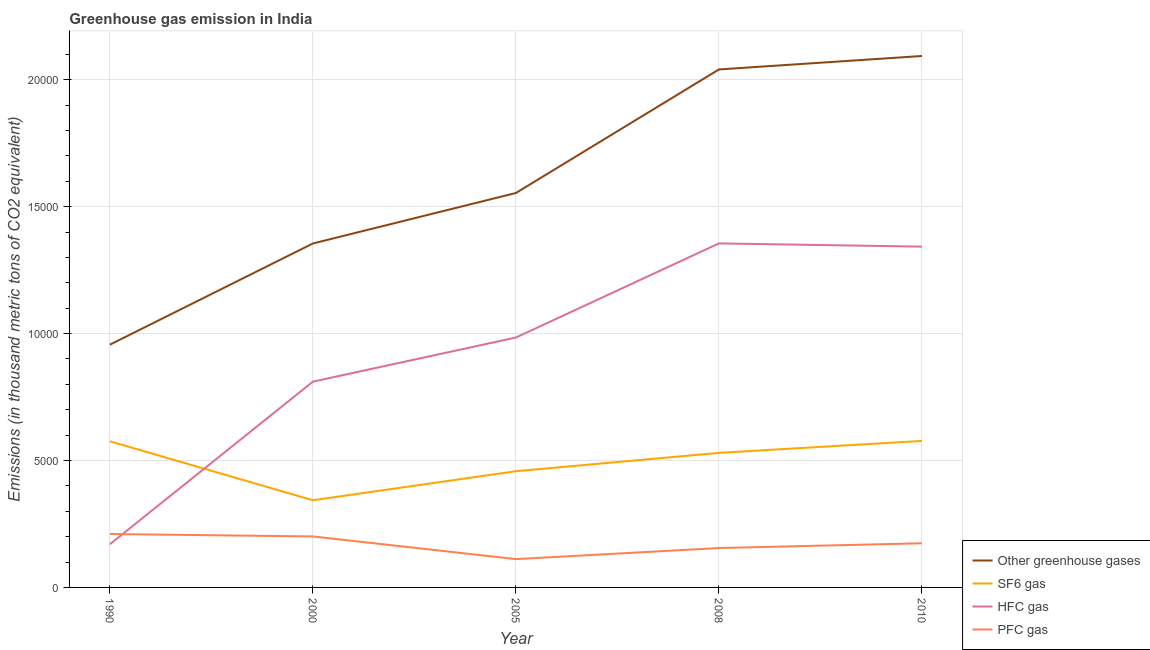How many different coloured lines are there?
Give a very brief answer. 4. What is the emission of hfc gas in 2000?
Your answer should be very brief. 8107.2. Across all years, what is the maximum emission of pfc gas?
Make the answer very short. 2104. Across all years, what is the minimum emission of sf6 gas?
Offer a terse response. 3434.7. In which year was the emission of sf6 gas maximum?
Provide a succinct answer. 2010. In which year was the emission of pfc gas minimum?
Offer a terse response. 2005. What is the total emission of greenhouse gases in the graph?
Your answer should be compact. 8.00e+04. What is the difference between the emission of hfc gas in 2000 and that in 2008?
Your response must be concise. -5446.5. What is the difference between the emission of hfc gas in 2000 and the emission of sf6 gas in 2008?
Give a very brief answer. 2805.8. What is the average emission of pfc gas per year?
Provide a succinct answer. 1704.08. In the year 2008, what is the difference between the emission of sf6 gas and emission of greenhouse gases?
Your answer should be very brief. -1.51e+04. In how many years, is the emission of hfc gas greater than 8000 thousand metric tons?
Give a very brief answer. 4. What is the ratio of the emission of sf6 gas in 2000 to that in 2010?
Ensure brevity in your answer.  0.6. Is the difference between the emission of greenhouse gases in 1990 and 2008 greater than the difference between the emission of sf6 gas in 1990 and 2008?
Provide a succinct answer. No. What is the difference between the highest and the lowest emission of hfc gas?
Keep it short and to the point. 1.19e+04. In how many years, is the emission of greenhouse gases greater than the average emission of greenhouse gases taken over all years?
Your answer should be very brief. 2. Is the sum of the emission of sf6 gas in 1990 and 2010 greater than the maximum emission of hfc gas across all years?
Ensure brevity in your answer.  No. Is it the case that in every year, the sum of the emission of greenhouse gases and emission of sf6 gas is greater than the sum of emission of pfc gas and emission of hfc gas?
Offer a very short reply. Yes. Does the emission of greenhouse gases monotonically increase over the years?
Your response must be concise. Yes. Is the emission of sf6 gas strictly greater than the emission of greenhouse gases over the years?
Your answer should be very brief. No. Is the emission of sf6 gas strictly less than the emission of hfc gas over the years?
Make the answer very short. No. What is the difference between two consecutive major ticks on the Y-axis?
Your response must be concise. 5000. Are the values on the major ticks of Y-axis written in scientific E-notation?
Your answer should be very brief. No. Does the graph contain any zero values?
Offer a very short reply. No. Does the graph contain grids?
Your answer should be very brief. Yes. How many legend labels are there?
Keep it short and to the point. 4. How are the legend labels stacked?
Make the answer very short. Vertical. What is the title of the graph?
Offer a very short reply. Greenhouse gas emission in India. Does "Third 20% of population" appear as one of the legend labels in the graph?
Give a very brief answer. No. What is the label or title of the Y-axis?
Ensure brevity in your answer.  Emissions (in thousand metric tons of CO2 equivalent). What is the Emissions (in thousand metric tons of CO2 equivalent) in Other greenhouse gases in 1990?
Your answer should be compact. 9563.6. What is the Emissions (in thousand metric tons of CO2 equivalent) of SF6 gas in 1990?
Offer a very short reply. 5757.5. What is the Emissions (in thousand metric tons of CO2 equivalent) in HFC gas in 1990?
Offer a terse response. 1702.1. What is the Emissions (in thousand metric tons of CO2 equivalent) in PFC gas in 1990?
Keep it short and to the point. 2104. What is the Emissions (in thousand metric tons of CO2 equivalent) of Other greenhouse gases in 2000?
Provide a short and direct response. 1.36e+04. What is the Emissions (in thousand metric tons of CO2 equivalent) in SF6 gas in 2000?
Provide a short and direct response. 3434.7. What is the Emissions (in thousand metric tons of CO2 equivalent) of HFC gas in 2000?
Your answer should be compact. 8107.2. What is the Emissions (in thousand metric tons of CO2 equivalent) of PFC gas in 2000?
Offer a very short reply. 2008.8. What is the Emissions (in thousand metric tons of CO2 equivalent) of Other greenhouse gases in 2005?
Give a very brief answer. 1.55e+04. What is the Emissions (in thousand metric tons of CO2 equivalent) in SF6 gas in 2005?
Offer a very short reply. 4578.7. What is the Emissions (in thousand metric tons of CO2 equivalent) of HFC gas in 2005?
Provide a short and direct response. 9845.2. What is the Emissions (in thousand metric tons of CO2 equivalent) in PFC gas in 2005?
Give a very brief answer. 1115.8. What is the Emissions (in thousand metric tons of CO2 equivalent) of Other greenhouse gases in 2008?
Give a very brief answer. 2.04e+04. What is the Emissions (in thousand metric tons of CO2 equivalent) of SF6 gas in 2008?
Offer a very short reply. 5301.4. What is the Emissions (in thousand metric tons of CO2 equivalent) in HFC gas in 2008?
Give a very brief answer. 1.36e+04. What is the Emissions (in thousand metric tons of CO2 equivalent) of PFC gas in 2008?
Offer a terse response. 1551.8. What is the Emissions (in thousand metric tons of CO2 equivalent) in Other greenhouse gases in 2010?
Keep it short and to the point. 2.09e+04. What is the Emissions (in thousand metric tons of CO2 equivalent) in SF6 gas in 2010?
Offer a terse response. 5772. What is the Emissions (in thousand metric tons of CO2 equivalent) of HFC gas in 2010?
Offer a very short reply. 1.34e+04. What is the Emissions (in thousand metric tons of CO2 equivalent) in PFC gas in 2010?
Your response must be concise. 1740. Across all years, what is the maximum Emissions (in thousand metric tons of CO2 equivalent) in Other greenhouse gases?
Offer a terse response. 2.09e+04. Across all years, what is the maximum Emissions (in thousand metric tons of CO2 equivalent) in SF6 gas?
Provide a short and direct response. 5772. Across all years, what is the maximum Emissions (in thousand metric tons of CO2 equivalent) in HFC gas?
Ensure brevity in your answer.  1.36e+04. Across all years, what is the maximum Emissions (in thousand metric tons of CO2 equivalent) in PFC gas?
Provide a short and direct response. 2104. Across all years, what is the minimum Emissions (in thousand metric tons of CO2 equivalent) of Other greenhouse gases?
Your response must be concise. 9563.6. Across all years, what is the minimum Emissions (in thousand metric tons of CO2 equivalent) in SF6 gas?
Offer a very short reply. 3434.7. Across all years, what is the minimum Emissions (in thousand metric tons of CO2 equivalent) of HFC gas?
Provide a succinct answer. 1702.1. Across all years, what is the minimum Emissions (in thousand metric tons of CO2 equivalent) in PFC gas?
Provide a short and direct response. 1115.8. What is the total Emissions (in thousand metric tons of CO2 equivalent) in Other greenhouse gases in the graph?
Provide a succinct answer. 8.00e+04. What is the total Emissions (in thousand metric tons of CO2 equivalent) in SF6 gas in the graph?
Your answer should be compact. 2.48e+04. What is the total Emissions (in thousand metric tons of CO2 equivalent) in HFC gas in the graph?
Keep it short and to the point. 4.66e+04. What is the total Emissions (in thousand metric tons of CO2 equivalent) of PFC gas in the graph?
Make the answer very short. 8520.4. What is the difference between the Emissions (in thousand metric tons of CO2 equivalent) in Other greenhouse gases in 1990 and that in 2000?
Provide a succinct answer. -3987.1. What is the difference between the Emissions (in thousand metric tons of CO2 equivalent) in SF6 gas in 1990 and that in 2000?
Your response must be concise. 2322.8. What is the difference between the Emissions (in thousand metric tons of CO2 equivalent) in HFC gas in 1990 and that in 2000?
Your answer should be compact. -6405.1. What is the difference between the Emissions (in thousand metric tons of CO2 equivalent) in PFC gas in 1990 and that in 2000?
Provide a succinct answer. 95.2. What is the difference between the Emissions (in thousand metric tons of CO2 equivalent) in Other greenhouse gases in 1990 and that in 2005?
Offer a very short reply. -5976.1. What is the difference between the Emissions (in thousand metric tons of CO2 equivalent) in SF6 gas in 1990 and that in 2005?
Provide a short and direct response. 1178.8. What is the difference between the Emissions (in thousand metric tons of CO2 equivalent) in HFC gas in 1990 and that in 2005?
Offer a terse response. -8143.1. What is the difference between the Emissions (in thousand metric tons of CO2 equivalent) of PFC gas in 1990 and that in 2005?
Keep it short and to the point. 988.2. What is the difference between the Emissions (in thousand metric tons of CO2 equivalent) in Other greenhouse gases in 1990 and that in 2008?
Offer a terse response. -1.08e+04. What is the difference between the Emissions (in thousand metric tons of CO2 equivalent) of SF6 gas in 1990 and that in 2008?
Ensure brevity in your answer.  456.1. What is the difference between the Emissions (in thousand metric tons of CO2 equivalent) of HFC gas in 1990 and that in 2008?
Provide a short and direct response. -1.19e+04. What is the difference between the Emissions (in thousand metric tons of CO2 equivalent) of PFC gas in 1990 and that in 2008?
Keep it short and to the point. 552.2. What is the difference between the Emissions (in thousand metric tons of CO2 equivalent) in Other greenhouse gases in 1990 and that in 2010?
Your answer should be very brief. -1.14e+04. What is the difference between the Emissions (in thousand metric tons of CO2 equivalent) in HFC gas in 1990 and that in 2010?
Provide a short and direct response. -1.17e+04. What is the difference between the Emissions (in thousand metric tons of CO2 equivalent) in PFC gas in 1990 and that in 2010?
Keep it short and to the point. 364. What is the difference between the Emissions (in thousand metric tons of CO2 equivalent) of Other greenhouse gases in 2000 and that in 2005?
Your response must be concise. -1989. What is the difference between the Emissions (in thousand metric tons of CO2 equivalent) in SF6 gas in 2000 and that in 2005?
Make the answer very short. -1144. What is the difference between the Emissions (in thousand metric tons of CO2 equivalent) of HFC gas in 2000 and that in 2005?
Make the answer very short. -1738. What is the difference between the Emissions (in thousand metric tons of CO2 equivalent) in PFC gas in 2000 and that in 2005?
Ensure brevity in your answer.  893. What is the difference between the Emissions (in thousand metric tons of CO2 equivalent) in Other greenhouse gases in 2000 and that in 2008?
Your answer should be very brief. -6856.2. What is the difference between the Emissions (in thousand metric tons of CO2 equivalent) in SF6 gas in 2000 and that in 2008?
Offer a terse response. -1866.7. What is the difference between the Emissions (in thousand metric tons of CO2 equivalent) of HFC gas in 2000 and that in 2008?
Keep it short and to the point. -5446.5. What is the difference between the Emissions (in thousand metric tons of CO2 equivalent) in PFC gas in 2000 and that in 2008?
Offer a very short reply. 457. What is the difference between the Emissions (in thousand metric tons of CO2 equivalent) in Other greenhouse gases in 2000 and that in 2010?
Make the answer very short. -7386.3. What is the difference between the Emissions (in thousand metric tons of CO2 equivalent) of SF6 gas in 2000 and that in 2010?
Give a very brief answer. -2337.3. What is the difference between the Emissions (in thousand metric tons of CO2 equivalent) of HFC gas in 2000 and that in 2010?
Your answer should be very brief. -5317.8. What is the difference between the Emissions (in thousand metric tons of CO2 equivalent) of PFC gas in 2000 and that in 2010?
Give a very brief answer. 268.8. What is the difference between the Emissions (in thousand metric tons of CO2 equivalent) in Other greenhouse gases in 2005 and that in 2008?
Make the answer very short. -4867.2. What is the difference between the Emissions (in thousand metric tons of CO2 equivalent) of SF6 gas in 2005 and that in 2008?
Ensure brevity in your answer.  -722.7. What is the difference between the Emissions (in thousand metric tons of CO2 equivalent) of HFC gas in 2005 and that in 2008?
Provide a short and direct response. -3708.5. What is the difference between the Emissions (in thousand metric tons of CO2 equivalent) of PFC gas in 2005 and that in 2008?
Your response must be concise. -436. What is the difference between the Emissions (in thousand metric tons of CO2 equivalent) of Other greenhouse gases in 2005 and that in 2010?
Provide a short and direct response. -5397.3. What is the difference between the Emissions (in thousand metric tons of CO2 equivalent) of SF6 gas in 2005 and that in 2010?
Offer a terse response. -1193.3. What is the difference between the Emissions (in thousand metric tons of CO2 equivalent) in HFC gas in 2005 and that in 2010?
Provide a succinct answer. -3579.8. What is the difference between the Emissions (in thousand metric tons of CO2 equivalent) in PFC gas in 2005 and that in 2010?
Your answer should be very brief. -624.2. What is the difference between the Emissions (in thousand metric tons of CO2 equivalent) of Other greenhouse gases in 2008 and that in 2010?
Ensure brevity in your answer.  -530.1. What is the difference between the Emissions (in thousand metric tons of CO2 equivalent) of SF6 gas in 2008 and that in 2010?
Provide a short and direct response. -470.6. What is the difference between the Emissions (in thousand metric tons of CO2 equivalent) in HFC gas in 2008 and that in 2010?
Ensure brevity in your answer.  128.7. What is the difference between the Emissions (in thousand metric tons of CO2 equivalent) in PFC gas in 2008 and that in 2010?
Make the answer very short. -188.2. What is the difference between the Emissions (in thousand metric tons of CO2 equivalent) of Other greenhouse gases in 1990 and the Emissions (in thousand metric tons of CO2 equivalent) of SF6 gas in 2000?
Ensure brevity in your answer.  6128.9. What is the difference between the Emissions (in thousand metric tons of CO2 equivalent) in Other greenhouse gases in 1990 and the Emissions (in thousand metric tons of CO2 equivalent) in HFC gas in 2000?
Provide a short and direct response. 1456.4. What is the difference between the Emissions (in thousand metric tons of CO2 equivalent) in Other greenhouse gases in 1990 and the Emissions (in thousand metric tons of CO2 equivalent) in PFC gas in 2000?
Provide a short and direct response. 7554.8. What is the difference between the Emissions (in thousand metric tons of CO2 equivalent) in SF6 gas in 1990 and the Emissions (in thousand metric tons of CO2 equivalent) in HFC gas in 2000?
Your response must be concise. -2349.7. What is the difference between the Emissions (in thousand metric tons of CO2 equivalent) of SF6 gas in 1990 and the Emissions (in thousand metric tons of CO2 equivalent) of PFC gas in 2000?
Ensure brevity in your answer.  3748.7. What is the difference between the Emissions (in thousand metric tons of CO2 equivalent) of HFC gas in 1990 and the Emissions (in thousand metric tons of CO2 equivalent) of PFC gas in 2000?
Your response must be concise. -306.7. What is the difference between the Emissions (in thousand metric tons of CO2 equivalent) of Other greenhouse gases in 1990 and the Emissions (in thousand metric tons of CO2 equivalent) of SF6 gas in 2005?
Your response must be concise. 4984.9. What is the difference between the Emissions (in thousand metric tons of CO2 equivalent) of Other greenhouse gases in 1990 and the Emissions (in thousand metric tons of CO2 equivalent) of HFC gas in 2005?
Your response must be concise. -281.6. What is the difference between the Emissions (in thousand metric tons of CO2 equivalent) of Other greenhouse gases in 1990 and the Emissions (in thousand metric tons of CO2 equivalent) of PFC gas in 2005?
Provide a succinct answer. 8447.8. What is the difference between the Emissions (in thousand metric tons of CO2 equivalent) of SF6 gas in 1990 and the Emissions (in thousand metric tons of CO2 equivalent) of HFC gas in 2005?
Provide a succinct answer. -4087.7. What is the difference between the Emissions (in thousand metric tons of CO2 equivalent) of SF6 gas in 1990 and the Emissions (in thousand metric tons of CO2 equivalent) of PFC gas in 2005?
Your answer should be very brief. 4641.7. What is the difference between the Emissions (in thousand metric tons of CO2 equivalent) in HFC gas in 1990 and the Emissions (in thousand metric tons of CO2 equivalent) in PFC gas in 2005?
Give a very brief answer. 586.3. What is the difference between the Emissions (in thousand metric tons of CO2 equivalent) in Other greenhouse gases in 1990 and the Emissions (in thousand metric tons of CO2 equivalent) in SF6 gas in 2008?
Your response must be concise. 4262.2. What is the difference between the Emissions (in thousand metric tons of CO2 equivalent) of Other greenhouse gases in 1990 and the Emissions (in thousand metric tons of CO2 equivalent) of HFC gas in 2008?
Offer a very short reply. -3990.1. What is the difference between the Emissions (in thousand metric tons of CO2 equivalent) of Other greenhouse gases in 1990 and the Emissions (in thousand metric tons of CO2 equivalent) of PFC gas in 2008?
Your answer should be compact. 8011.8. What is the difference between the Emissions (in thousand metric tons of CO2 equivalent) in SF6 gas in 1990 and the Emissions (in thousand metric tons of CO2 equivalent) in HFC gas in 2008?
Provide a succinct answer. -7796.2. What is the difference between the Emissions (in thousand metric tons of CO2 equivalent) in SF6 gas in 1990 and the Emissions (in thousand metric tons of CO2 equivalent) in PFC gas in 2008?
Your answer should be very brief. 4205.7. What is the difference between the Emissions (in thousand metric tons of CO2 equivalent) of HFC gas in 1990 and the Emissions (in thousand metric tons of CO2 equivalent) of PFC gas in 2008?
Keep it short and to the point. 150.3. What is the difference between the Emissions (in thousand metric tons of CO2 equivalent) in Other greenhouse gases in 1990 and the Emissions (in thousand metric tons of CO2 equivalent) in SF6 gas in 2010?
Provide a succinct answer. 3791.6. What is the difference between the Emissions (in thousand metric tons of CO2 equivalent) of Other greenhouse gases in 1990 and the Emissions (in thousand metric tons of CO2 equivalent) of HFC gas in 2010?
Make the answer very short. -3861.4. What is the difference between the Emissions (in thousand metric tons of CO2 equivalent) in Other greenhouse gases in 1990 and the Emissions (in thousand metric tons of CO2 equivalent) in PFC gas in 2010?
Make the answer very short. 7823.6. What is the difference between the Emissions (in thousand metric tons of CO2 equivalent) in SF6 gas in 1990 and the Emissions (in thousand metric tons of CO2 equivalent) in HFC gas in 2010?
Offer a very short reply. -7667.5. What is the difference between the Emissions (in thousand metric tons of CO2 equivalent) in SF6 gas in 1990 and the Emissions (in thousand metric tons of CO2 equivalent) in PFC gas in 2010?
Offer a terse response. 4017.5. What is the difference between the Emissions (in thousand metric tons of CO2 equivalent) of HFC gas in 1990 and the Emissions (in thousand metric tons of CO2 equivalent) of PFC gas in 2010?
Your response must be concise. -37.9. What is the difference between the Emissions (in thousand metric tons of CO2 equivalent) in Other greenhouse gases in 2000 and the Emissions (in thousand metric tons of CO2 equivalent) in SF6 gas in 2005?
Your response must be concise. 8972. What is the difference between the Emissions (in thousand metric tons of CO2 equivalent) of Other greenhouse gases in 2000 and the Emissions (in thousand metric tons of CO2 equivalent) of HFC gas in 2005?
Give a very brief answer. 3705.5. What is the difference between the Emissions (in thousand metric tons of CO2 equivalent) of Other greenhouse gases in 2000 and the Emissions (in thousand metric tons of CO2 equivalent) of PFC gas in 2005?
Make the answer very short. 1.24e+04. What is the difference between the Emissions (in thousand metric tons of CO2 equivalent) in SF6 gas in 2000 and the Emissions (in thousand metric tons of CO2 equivalent) in HFC gas in 2005?
Provide a short and direct response. -6410.5. What is the difference between the Emissions (in thousand metric tons of CO2 equivalent) in SF6 gas in 2000 and the Emissions (in thousand metric tons of CO2 equivalent) in PFC gas in 2005?
Your answer should be compact. 2318.9. What is the difference between the Emissions (in thousand metric tons of CO2 equivalent) in HFC gas in 2000 and the Emissions (in thousand metric tons of CO2 equivalent) in PFC gas in 2005?
Your answer should be compact. 6991.4. What is the difference between the Emissions (in thousand metric tons of CO2 equivalent) in Other greenhouse gases in 2000 and the Emissions (in thousand metric tons of CO2 equivalent) in SF6 gas in 2008?
Your answer should be very brief. 8249.3. What is the difference between the Emissions (in thousand metric tons of CO2 equivalent) of Other greenhouse gases in 2000 and the Emissions (in thousand metric tons of CO2 equivalent) of PFC gas in 2008?
Ensure brevity in your answer.  1.20e+04. What is the difference between the Emissions (in thousand metric tons of CO2 equivalent) of SF6 gas in 2000 and the Emissions (in thousand metric tons of CO2 equivalent) of HFC gas in 2008?
Provide a short and direct response. -1.01e+04. What is the difference between the Emissions (in thousand metric tons of CO2 equivalent) of SF6 gas in 2000 and the Emissions (in thousand metric tons of CO2 equivalent) of PFC gas in 2008?
Offer a terse response. 1882.9. What is the difference between the Emissions (in thousand metric tons of CO2 equivalent) in HFC gas in 2000 and the Emissions (in thousand metric tons of CO2 equivalent) in PFC gas in 2008?
Your response must be concise. 6555.4. What is the difference between the Emissions (in thousand metric tons of CO2 equivalent) in Other greenhouse gases in 2000 and the Emissions (in thousand metric tons of CO2 equivalent) in SF6 gas in 2010?
Provide a succinct answer. 7778.7. What is the difference between the Emissions (in thousand metric tons of CO2 equivalent) in Other greenhouse gases in 2000 and the Emissions (in thousand metric tons of CO2 equivalent) in HFC gas in 2010?
Keep it short and to the point. 125.7. What is the difference between the Emissions (in thousand metric tons of CO2 equivalent) in Other greenhouse gases in 2000 and the Emissions (in thousand metric tons of CO2 equivalent) in PFC gas in 2010?
Your answer should be compact. 1.18e+04. What is the difference between the Emissions (in thousand metric tons of CO2 equivalent) of SF6 gas in 2000 and the Emissions (in thousand metric tons of CO2 equivalent) of HFC gas in 2010?
Make the answer very short. -9990.3. What is the difference between the Emissions (in thousand metric tons of CO2 equivalent) of SF6 gas in 2000 and the Emissions (in thousand metric tons of CO2 equivalent) of PFC gas in 2010?
Offer a terse response. 1694.7. What is the difference between the Emissions (in thousand metric tons of CO2 equivalent) of HFC gas in 2000 and the Emissions (in thousand metric tons of CO2 equivalent) of PFC gas in 2010?
Your answer should be compact. 6367.2. What is the difference between the Emissions (in thousand metric tons of CO2 equivalent) in Other greenhouse gases in 2005 and the Emissions (in thousand metric tons of CO2 equivalent) in SF6 gas in 2008?
Ensure brevity in your answer.  1.02e+04. What is the difference between the Emissions (in thousand metric tons of CO2 equivalent) in Other greenhouse gases in 2005 and the Emissions (in thousand metric tons of CO2 equivalent) in HFC gas in 2008?
Provide a short and direct response. 1986. What is the difference between the Emissions (in thousand metric tons of CO2 equivalent) of Other greenhouse gases in 2005 and the Emissions (in thousand metric tons of CO2 equivalent) of PFC gas in 2008?
Provide a short and direct response. 1.40e+04. What is the difference between the Emissions (in thousand metric tons of CO2 equivalent) of SF6 gas in 2005 and the Emissions (in thousand metric tons of CO2 equivalent) of HFC gas in 2008?
Offer a very short reply. -8975. What is the difference between the Emissions (in thousand metric tons of CO2 equivalent) of SF6 gas in 2005 and the Emissions (in thousand metric tons of CO2 equivalent) of PFC gas in 2008?
Provide a succinct answer. 3026.9. What is the difference between the Emissions (in thousand metric tons of CO2 equivalent) of HFC gas in 2005 and the Emissions (in thousand metric tons of CO2 equivalent) of PFC gas in 2008?
Your answer should be compact. 8293.4. What is the difference between the Emissions (in thousand metric tons of CO2 equivalent) in Other greenhouse gases in 2005 and the Emissions (in thousand metric tons of CO2 equivalent) in SF6 gas in 2010?
Your answer should be compact. 9767.7. What is the difference between the Emissions (in thousand metric tons of CO2 equivalent) of Other greenhouse gases in 2005 and the Emissions (in thousand metric tons of CO2 equivalent) of HFC gas in 2010?
Ensure brevity in your answer.  2114.7. What is the difference between the Emissions (in thousand metric tons of CO2 equivalent) of Other greenhouse gases in 2005 and the Emissions (in thousand metric tons of CO2 equivalent) of PFC gas in 2010?
Provide a short and direct response. 1.38e+04. What is the difference between the Emissions (in thousand metric tons of CO2 equivalent) in SF6 gas in 2005 and the Emissions (in thousand metric tons of CO2 equivalent) in HFC gas in 2010?
Keep it short and to the point. -8846.3. What is the difference between the Emissions (in thousand metric tons of CO2 equivalent) in SF6 gas in 2005 and the Emissions (in thousand metric tons of CO2 equivalent) in PFC gas in 2010?
Offer a terse response. 2838.7. What is the difference between the Emissions (in thousand metric tons of CO2 equivalent) in HFC gas in 2005 and the Emissions (in thousand metric tons of CO2 equivalent) in PFC gas in 2010?
Offer a very short reply. 8105.2. What is the difference between the Emissions (in thousand metric tons of CO2 equivalent) in Other greenhouse gases in 2008 and the Emissions (in thousand metric tons of CO2 equivalent) in SF6 gas in 2010?
Keep it short and to the point. 1.46e+04. What is the difference between the Emissions (in thousand metric tons of CO2 equivalent) of Other greenhouse gases in 2008 and the Emissions (in thousand metric tons of CO2 equivalent) of HFC gas in 2010?
Ensure brevity in your answer.  6981.9. What is the difference between the Emissions (in thousand metric tons of CO2 equivalent) in Other greenhouse gases in 2008 and the Emissions (in thousand metric tons of CO2 equivalent) in PFC gas in 2010?
Make the answer very short. 1.87e+04. What is the difference between the Emissions (in thousand metric tons of CO2 equivalent) of SF6 gas in 2008 and the Emissions (in thousand metric tons of CO2 equivalent) of HFC gas in 2010?
Provide a short and direct response. -8123.6. What is the difference between the Emissions (in thousand metric tons of CO2 equivalent) in SF6 gas in 2008 and the Emissions (in thousand metric tons of CO2 equivalent) in PFC gas in 2010?
Provide a succinct answer. 3561.4. What is the difference between the Emissions (in thousand metric tons of CO2 equivalent) of HFC gas in 2008 and the Emissions (in thousand metric tons of CO2 equivalent) of PFC gas in 2010?
Offer a very short reply. 1.18e+04. What is the average Emissions (in thousand metric tons of CO2 equivalent) in Other greenhouse gases per year?
Your answer should be compact. 1.60e+04. What is the average Emissions (in thousand metric tons of CO2 equivalent) in SF6 gas per year?
Make the answer very short. 4968.86. What is the average Emissions (in thousand metric tons of CO2 equivalent) in HFC gas per year?
Provide a short and direct response. 9326.64. What is the average Emissions (in thousand metric tons of CO2 equivalent) in PFC gas per year?
Provide a short and direct response. 1704.08. In the year 1990, what is the difference between the Emissions (in thousand metric tons of CO2 equivalent) in Other greenhouse gases and Emissions (in thousand metric tons of CO2 equivalent) in SF6 gas?
Keep it short and to the point. 3806.1. In the year 1990, what is the difference between the Emissions (in thousand metric tons of CO2 equivalent) in Other greenhouse gases and Emissions (in thousand metric tons of CO2 equivalent) in HFC gas?
Your response must be concise. 7861.5. In the year 1990, what is the difference between the Emissions (in thousand metric tons of CO2 equivalent) of Other greenhouse gases and Emissions (in thousand metric tons of CO2 equivalent) of PFC gas?
Provide a succinct answer. 7459.6. In the year 1990, what is the difference between the Emissions (in thousand metric tons of CO2 equivalent) in SF6 gas and Emissions (in thousand metric tons of CO2 equivalent) in HFC gas?
Make the answer very short. 4055.4. In the year 1990, what is the difference between the Emissions (in thousand metric tons of CO2 equivalent) in SF6 gas and Emissions (in thousand metric tons of CO2 equivalent) in PFC gas?
Offer a very short reply. 3653.5. In the year 1990, what is the difference between the Emissions (in thousand metric tons of CO2 equivalent) in HFC gas and Emissions (in thousand metric tons of CO2 equivalent) in PFC gas?
Give a very brief answer. -401.9. In the year 2000, what is the difference between the Emissions (in thousand metric tons of CO2 equivalent) of Other greenhouse gases and Emissions (in thousand metric tons of CO2 equivalent) of SF6 gas?
Offer a very short reply. 1.01e+04. In the year 2000, what is the difference between the Emissions (in thousand metric tons of CO2 equivalent) of Other greenhouse gases and Emissions (in thousand metric tons of CO2 equivalent) of HFC gas?
Your answer should be compact. 5443.5. In the year 2000, what is the difference between the Emissions (in thousand metric tons of CO2 equivalent) of Other greenhouse gases and Emissions (in thousand metric tons of CO2 equivalent) of PFC gas?
Your answer should be compact. 1.15e+04. In the year 2000, what is the difference between the Emissions (in thousand metric tons of CO2 equivalent) of SF6 gas and Emissions (in thousand metric tons of CO2 equivalent) of HFC gas?
Your answer should be very brief. -4672.5. In the year 2000, what is the difference between the Emissions (in thousand metric tons of CO2 equivalent) in SF6 gas and Emissions (in thousand metric tons of CO2 equivalent) in PFC gas?
Make the answer very short. 1425.9. In the year 2000, what is the difference between the Emissions (in thousand metric tons of CO2 equivalent) in HFC gas and Emissions (in thousand metric tons of CO2 equivalent) in PFC gas?
Keep it short and to the point. 6098.4. In the year 2005, what is the difference between the Emissions (in thousand metric tons of CO2 equivalent) of Other greenhouse gases and Emissions (in thousand metric tons of CO2 equivalent) of SF6 gas?
Offer a terse response. 1.10e+04. In the year 2005, what is the difference between the Emissions (in thousand metric tons of CO2 equivalent) in Other greenhouse gases and Emissions (in thousand metric tons of CO2 equivalent) in HFC gas?
Make the answer very short. 5694.5. In the year 2005, what is the difference between the Emissions (in thousand metric tons of CO2 equivalent) of Other greenhouse gases and Emissions (in thousand metric tons of CO2 equivalent) of PFC gas?
Provide a succinct answer. 1.44e+04. In the year 2005, what is the difference between the Emissions (in thousand metric tons of CO2 equivalent) in SF6 gas and Emissions (in thousand metric tons of CO2 equivalent) in HFC gas?
Make the answer very short. -5266.5. In the year 2005, what is the difference between the Emissions (in thousand metric tons of CO2 equivalent) of SF6 gas and Emissions (in thousand metric tons of CO2 equivalent) of PFC gas?
Provide a short and direct response. 3462.9. In the year 2005, what is the difference between the Emissions (in thousand metric tons of CO2 equivalent) in HFC gas and Emissions (in thousand metric tons of CO2 equivalent) in PFC gas?
Keep it short and to the point. 8729.4. In the year 2008, what is the difference between the Emissions (in thousand metric tons of CO2 equivalent) of Other greenhouse gases and Emissions (in thousand metric tons of CO2 equivalent) of SF6 gas?
Ensure brevity in your answer.  1.51e+04. In the year 2008, what is the difference between the Emissions (in thousand metric tons of CO2 equivalent) of Other greenhouse gases and Emissions (in thousand metric tons of CO2 equivalent) of HFC gas?
Offer a terse response. 6853.2. In the year 2008, what is the difference between the Emissions (in thousand metric tons of CO2 equivalent) of Other greenhouse gases and Emissions (in thousand metric tons of CO2 equivalent) of PFC gas?
Provide a succinct answer. 1.89e+04. In the year 2008, what is the difference between the Emissions (in thousand metric tons of CO2 equivalent) in SF6 gas and Emissions (in thousand metric tons of CO2 equivalent) in HFC gas?
Your response must be concise. -8252.3. In the year 2008, what is the difference between the Emissions (in thousand metric tons of CO2 equivalent) in SF6 gas and Emissions (in thousand metric tons of CO2 equivalent) in PFC gas?
Make the answer very short. 3749.6. In the year 2008, what is the difference between the Emissions (in thousand metric tons of CO2 equivalent) in HFC gas and Emissions (in thousand metric tons of CO2 equivalent) in PFC gas?
Provide a short and direct response. 1.20e+04. In the year 2010, what is the difference between the Emissions (in thousand metric tons of CO2 equivalent) of Other greenhouse gases and Emissions (in thousand metric tons of CO2 equivalent) of SF6 gas?
Give a very brief answer. 1.52e+04. In the year 2010, what is the difference between the Emissions (in thousand metric tons of CO2 equivalent) in Other greenhouse gases and Emissions (in thousand metric tons of CO2 equivalent) in HFC gas?
Offer a very short reply. 7512. In the year 2010, what is the difference between the Emissions (in thousand metric tons of CO2 equivalent) of Other greenhouse gases and Emissions (in thousand metric tons of CO2 equivalent) of PFC gas?
Offer a terse response. 1.92e+04. In the year 2010, what is the difference between the Emissions (in thousand metric tons of CO2 equivalent) of SF6 gas and Emissions (in thousand metric tons of CO2 equivalent) of HFC gas?
Ensure brevity in your answer.  -7653. In the year 2010, what is the difference between the Emissions (in thousand metric tons of CO2 equivalent) of SF6 gas and Emissions (in thousand metric tons of CO2 equivalent) of PFC gas?
Your answer should be compact. 4032. In the year 2010, what is the difference between the Emissions (in thousand metric tons of CO2 equivalent) in HFC gas and Emissions (in thousand metric tons of CO2 equivalent) in PFC gas?
Ensure brevity in your answer.  1.17e+04. What is the ratio of the Emissions (in thousand metric tons of CO2 equivalent) in Other greenhouse gases in 1990 to that in 2000?
Keep it short and to the point. 0.71. What is the ratio of the Emissions (in thousand metric tons of CO2 equivalent) in SF6 gas in 1990 to that in 2000?
Give a very brief answer. 1.68. What is the ratio of the Emissions (in thousand metric tons of CO2 equivalent) in HFC gas in 1990 to that in 2000?
Offer a terse response. 0.21. What is the ratio of the Emissions (in thousand metric tons of CO2 equivalent) of PFC gas in 1990 to that in 2000?
Provide a short and direct response. 1.05. What is the ratio of the Emissions (in thousand metric tons of CO2 equivalent) of Other greenhouse gases in 1990 to that in 2005?
Give a very brief answer. 0.62. What is the ratio of the Emissions (in thousand metric tons of CO2 equivalent) in SF6 gas in 1990 to that in 2005?
Your answer should be very brief. 1.26. What is the ratio of the Emissions (in thousand metric tons of CO2 equivalent) of HFC gas in 1990 to that in 2005?
Offer a terse response. 0.17. What is the ratio of the Emissions (in thousand metric tons of CO2 equivalent) in PFC gas in 1990 to that in 2005?
Offer a very short reply. 1.89. What is the ratio of the Emissions (in thousand metric tons of CO2 equivalent) in Other greenhouse gases in 1990 to that in 2008?
Provide a short and direct response. 0.47. What is the ratio of the Emissions (in thousand metric tons of CO2 equivalent) of SF6 gas in 1990 to that in 2008?
Provide a succinct answer. 1.09. What is the ratio of the Emissions (in thousand metric tons of CO2 equivalent) in HFC gas in 1990 to that in 2008?
Keep it short and to the point. 0.13. What is the ratio of the Emissions (in thousand metric tons of CO2 equivalent) of PFC gas in 1990 to that in 2008?
Provide a short and direct response. 1.36. What is the ratio of the Emissions (in thousand metric tons of CO2 equivalent) of Other greenhouse gases in 1990 to that in 2010?
Give a very brief answer. 0.46. What is the ratio of the Emissions (in thousand metric tons of CO2 equivalent) in HFC gas in 1990 to that in 2010?
Ensure brevity in your answer.  0.13. What is the ratio of the Emissions (in thousand metric tons of CO2 equivalent) of PFC gas in 1990 to that in 2010?
Provide a short and direct response. 1.21. What is the ratio of the Emissions (in thousand metric tons of CO2 equivalent) in Other greenhouse gases in 2000 to that in 2005?
Make the answer very short. 0.87. What is the ratio of the Emissions (in thousand metric tons of CO2 equivalent) of SF6 gas in 2000 to that in 2005?
Provide a succinct answer. 0.75. What is the ratio of the Emissions (in thousand metric tons of CO2 equivalent) of HFC gas in 2000 to that in 2005?
Your answer should be very brief. 0.82. What is the ratio of the Emissions (in thousand metric tons of CO2 equivalent) in PFC gas in 2000 to that in 2005?
Offer a very short reply. 1.8. What is the ratio of the Emissions (in thousand metric tons of CO2 equivalent) in Other greenhouse gases in 2000 to that in 2008?
Offer a terse response. 0.66. What is the ratio of the Emissions (in thousand metric tons of CO2 equivalent) in SF6 gas in 2000 to that in 2008?
Make the answer very short. 0.65. What is the ratio of the Emissions (in thousand metric tons of CO2 equivalent) of HFC gas in 2000 to that in 2008?
Your answer should be very brief. 0.6. What is the ratio of the Emissions (in thousand metric tons of CO2 equivalent) of PFC gas in 2000 to that in 2008?
Ensure brevity in your answer.  1.29. What is the ratio of the Emissions (in thousand metric tons of CO2 equivalent) in Other greenhouse gases in 2000 to that in 2010?
Offer a very short reply. 0.65. What is the ratio of the Emissions (in thousand metric tons of CO2 equivalent) in SF6 gas in 2000 to that in 2010?
Offer a terse response. 0.6. What is the ratio of the Emissions (in thousand metric tons of CO2 equivalent) in HFC gas in 2000 to that in 2010?
Give a very brief answer. 0.6. What is the ratio of the Emissions (in thousand metric tons of CO2 equivalent) in PFC gas in 2000 to that in 2010?
Your answer should be very brief. 1.15. What is the ratio of the Emissions (in thousand metric tons of CO2 equivalent) in Other greenhouse gases in 2005 to that in 2008?
Make the answer very short. 0.76. What is the ratio of the Emissions (in thousand metric tons of CO2 equivalent) of SF6 gas in 2005 to that in 2008?
Give a very brief answer. 0.86. What is the ratio of the Emissions (in thousand metric tons of CO2 equivalent) of HFC gas in 2005 to that in 2008?
Provide a short and direct response. 0.73. What is the ratio of the Emissions (in thousand metric tons of CO2 equivalent) of PFC gas in 2005 to that in 2008?
Make the answer very short. 0.72. What is the ratio of the Emissions (in thousand metric tons of CO2 equivalent) of Other greenhouse gases in 2005 to that in 2010?
Provide a succinct answer. 0.74. What is the ratio of the Emissions (in thousand metric tons of CO2 equivalent) of SF6 gas in 2005 to that in 2010?
Make the answer very short. 0.79. What is the ratio of the Emissions (in thousand metric tons of CO2 equivalent) of HFC gas in 2005 to that in 2010?
Your response must be concise. 0.73. What is the ratio of the Emissions (in thousand metric tons of CO2 equivalent) of PFC gas in 2005 to that in 2010?
Offer a very short reply. 0.64. What is the ratio of the Emissions (in thousand metric tons of CO2 equivalent) in Other greenhouse gases in 2008 to that in 2010?
Offer a very short reply. 0.97. What is the ratio of the Emissions (in thousand metric tons of CO2 equivalent) of SF6 gas in 2008 to that in 2010?
Your response must be concise. 0.92. What is the ratio of the Emissions (in thousand metric tons of CO2 equivalent) in HFC gas in 2008 to that in 2010?
Your answer should be compact. 1.01. What is the ratio of the Emissions (in thousand metric tons of CO2 equivalent) of PFC gas in 2008 to that in 2010?
Give a very brief answer. 0.89. What is the difference between the highest and the second highest Emissions (in thousand metric tons of CO2 equivalent) of Other greenhouse gases?
Provide a succinct answer. 530.1. What is the difference between the highest and the second highest Emissions (in thousand metric tons of CO2 equivalent) in HFC gas?
Your answer should be very brief. 128.7. What is the difference between the highest and the second highest Emissions (in thousand metric tons of CO2 equivalent) of PFC gas?
Provide a succinct answer. 95.2. What is the difference between the highest and the lowest Emissions (in thousand metric tons of CO2 equivalent) in Other greenhouse gases?
Give a very brief answer. 1.14e+04. What is the difference between the highest and the lowest Emissions (in thousand metric tons of CO2 equivalent) in SF6 gas?
Your answer should be very brief. 2337.3. What is the difference between the highest and the lowest Emissions (in thousand metric tons of CO2 equivalent) of HFC gas?
Your answer should be compact. 1.19e+04. What is the difference between the highest and the lowest Emissions (in thousand metric tons of CO2 equivalent) of PFC gas?
Make the answer very short. 988.2. 